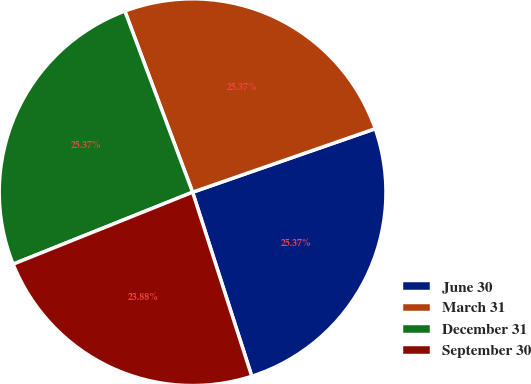<chart> <loc_0><loc_0><loc_500><loc_500><pie_chart><fcel>June 30<fcel>March 31<fcel>December 31<fcel>September 30<nl><fcel>25.37%<fcel>25.37%<fcel>25.37%<fcel>23.88%<nl></chart> 